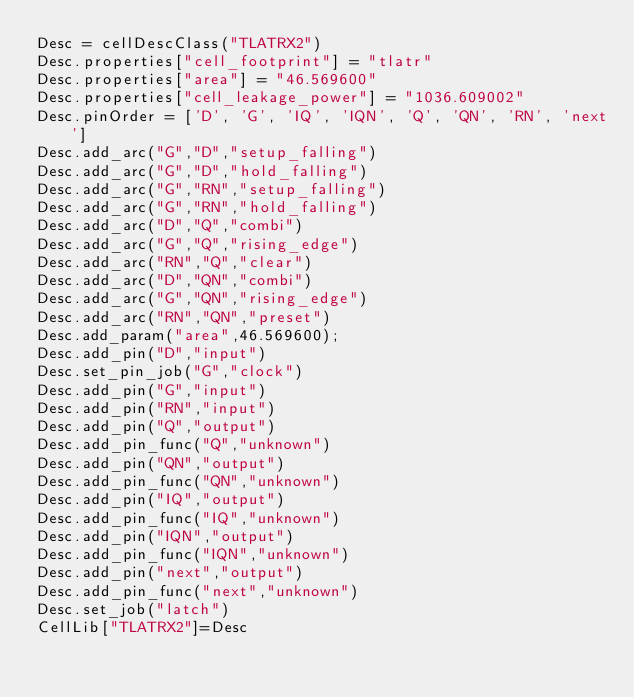<code> <loc_0><loc_0><loc_500><loc_500><_Python_>Desc = cellDescClass("TLATRX2")
Desc.properties["cell_footprint"] = "tlatr"
Desc.properties["area"] = "46.569600"
Desc.properties["cell_leakage_power"] = "1036.609002"
Desc.pinOrder = ['D', 'G', 'IQ', 'IQN', 'Q', 'QN', 'RN', 'next']
Desc.add_arc("G","D","setup_falling")
Desc.add_arc("G","D","hold_falling")
Desc.add_arc("G","RN","setup_falling")
Desc.add_arc("G","RN","hold_falling")
Desc.add_arc("D","Q","combi")
Desc.add_arc("G","Q","rising_edge")
Desc.add_arc("RN","Q","clear")
Desc.add_arc("D","QN","combi")
Desc.add_arc("G","QN","rising_edge")
Desc.add_arc("RN","QN","preset")
Desc.add_param("area",46.569600);
Desc.add_pin("D","input")
Desc.set_pin_job("G","clock")
Desc.add_pin("G","input")
Desc.add_pin("RN","input")
Desc.add_pin("Q","output")
Desc.add_pin_func("Q","unknown")
Desc.add_pin("QN","output")
Desc.add_pin_func("QN","unknown")
Desc.add_pin("IQ","output")
Desc.add_pin_func("IQ","unknown")
Desc.add_pin("IQN","output")
Desc.add_pin_func("IQN","unknown")
Desc.add_pin("next","output")
Desc.add_pin_func("next","unknown")
Desc.set_job("latch")
CellLib["TLATRX2"]=Desc
</code> 